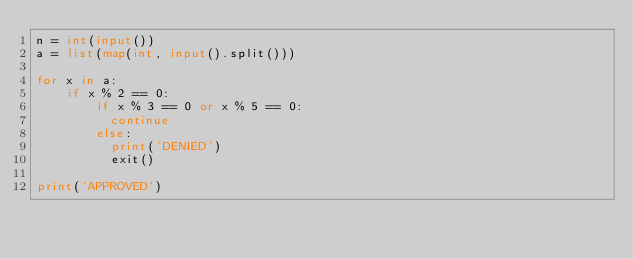<code> <loc_0><loc_0><loc_500><loc_500><_Python_>n = int(input())
a = list(map(int, input().split()))

for x in a:
    if x % 2 == 0:
        if x % 3 == 0 or x % 5 == 0:
          continue
        else:
          print('DENIED')
          exit()

print('APPROVED')</code> 